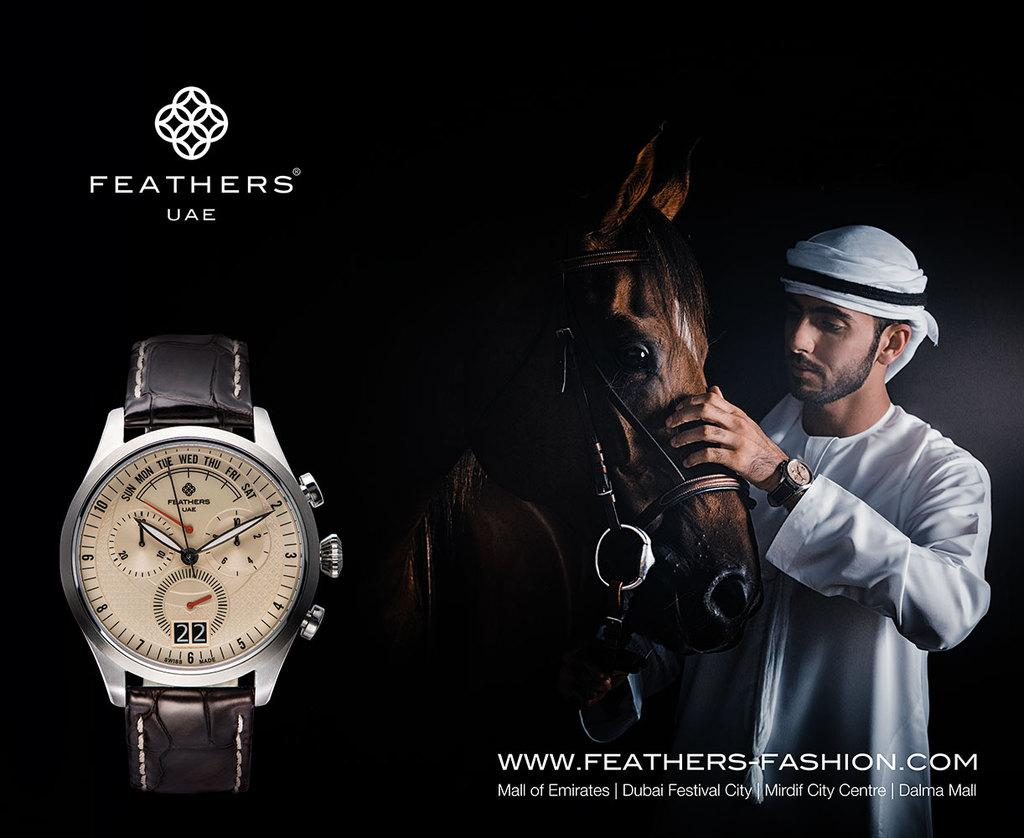Provide a one-sentence caption for the provided image. An advertisement for the watch brand Feathers UAE. 